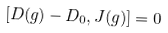Convert formula to latex. <formula><loc_0><loc_0><loc_500><loc_500>[ D ( g ) - D _ { 0 } , J ( g ) ] = 0 \,</formula> 